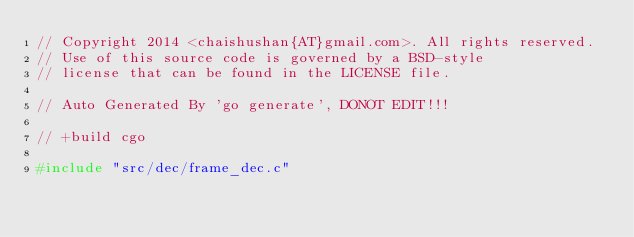Convert code to text. <code><loc_0><loc_0><loc_500><loc_500><_C_>// Copyright 2014 <chaishushan{AT}gmail.com>. All rights reserved.
// Use of this source code is governed by a BSD-style
// license that can be found in the LICENSE file.

// Auto Generated By 'go generate', DONOT EDIT!!!

// +build cgo

#include "src/dec/frame_dec.c"
</code> 